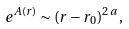<formula> <loc_0><loc_0><loc_500><loc_500>e ^ { A ( r ) } \sim ( r - r _ { 0 } ) ^ { 2 \, a } \, ,</formula> 